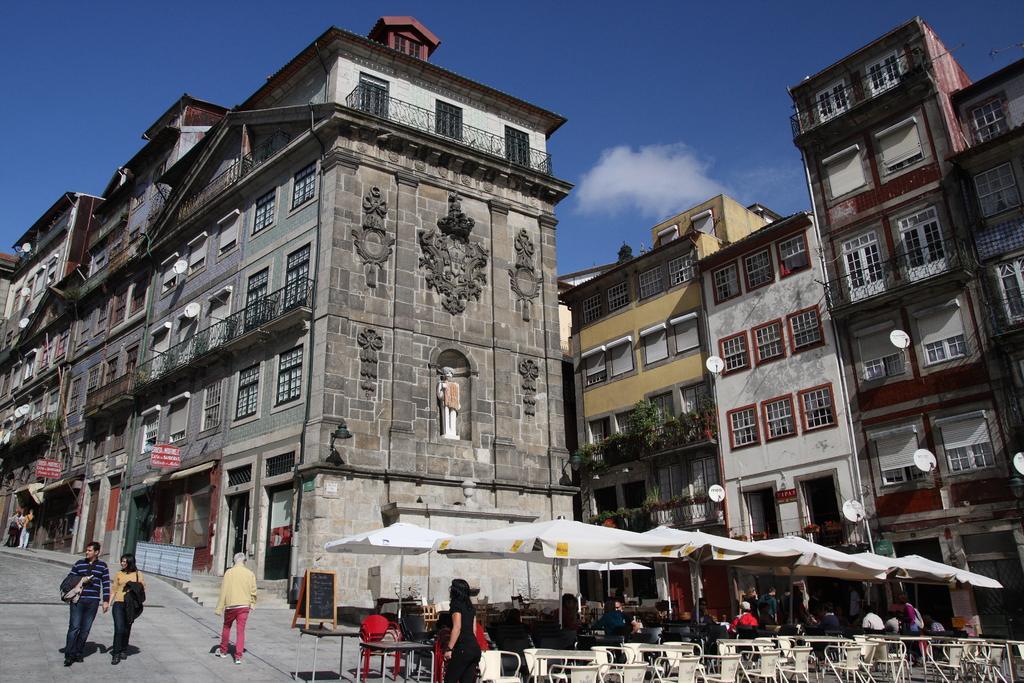In one or two sentences, can you explain what this image depicts? In this image we can see there are buildings with plants and boards with text and stairs. We can see there are few people walking on the ground and a few people sitting and there are chairs, tables and tent. At the top we can see the sky. 